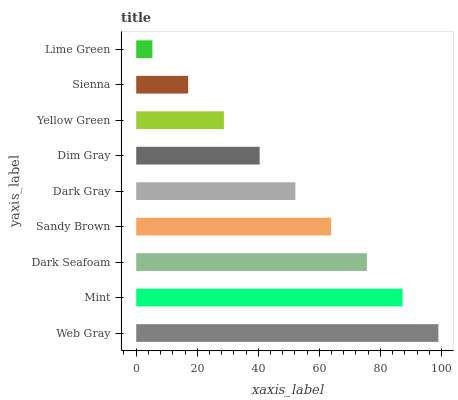Is Lime Green the minimum?
Answer yes or no. Yes. Is Web Gray the maximum?
Answer yes or no. Yes. Is Mint the minimum?
Answer yes or no. No. Is Mint the maximum?
Answer yes or no. No. Is Web Gray greater than Mint?
Answer yes or no. Yes. Is Mint less than Web Gray?
Answer yes or no. Yes. Is Mint greater than Web Gray?
Answer yes or no. No. Is Web Gray less than Mint?
Answer yes or no. No. Is Dark Gray the high median?
Answer yes or no. Yes. Is Dark Gray the low median?
Answer yes or no. Yes. Is Mint the high median?
Answer yes or no. No. Is Dim Gray the low median?
Answer yes or no. No. 